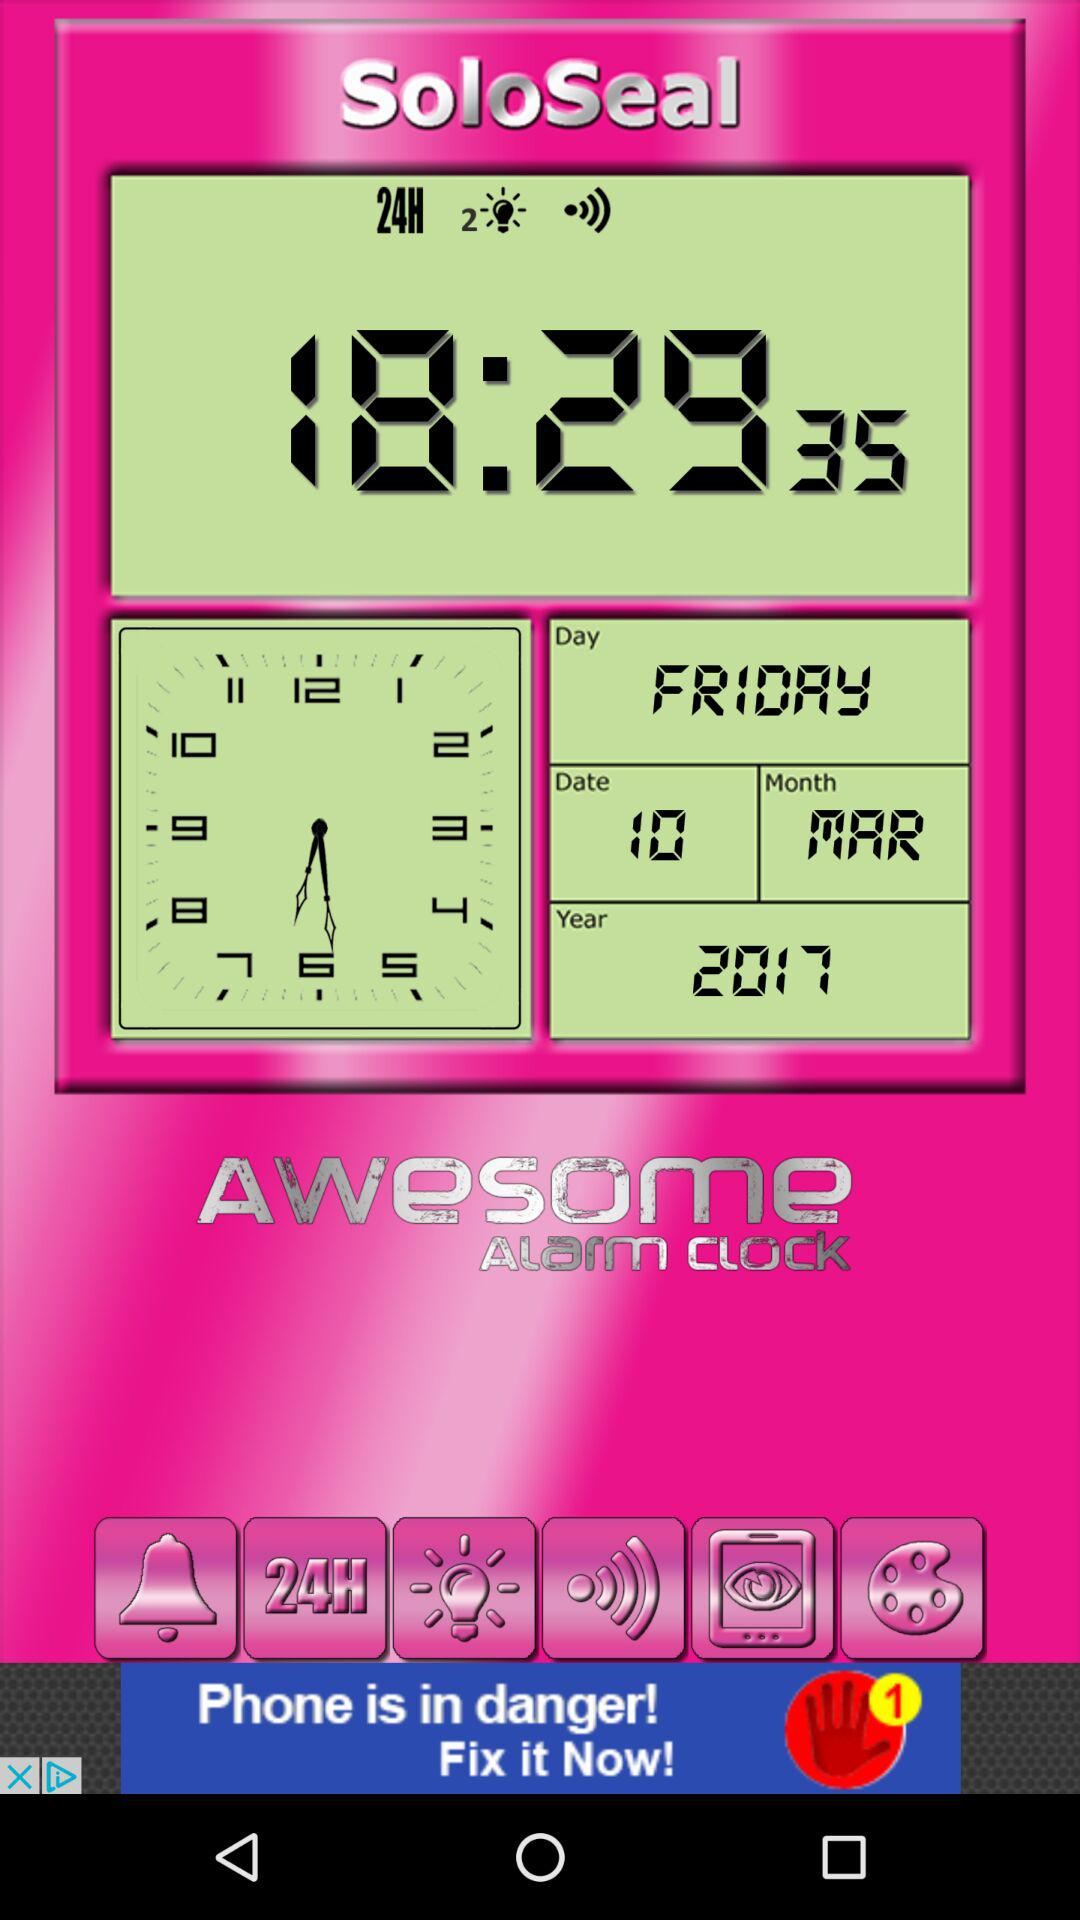What is the selected date? The selected date is Friday, March 10, 2017. 